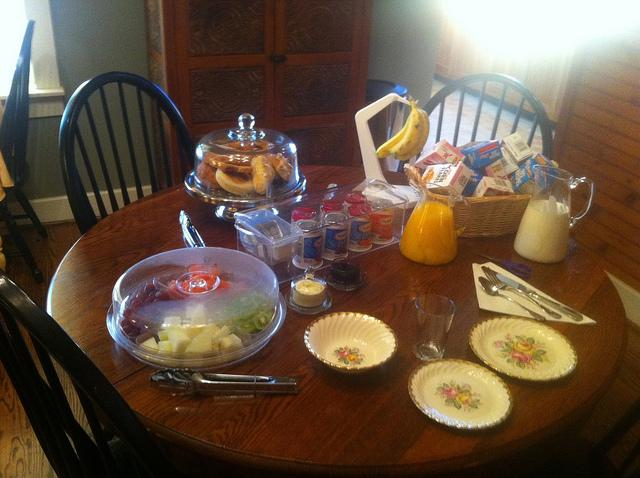What are the plastic lids used for when covering these trays of food? protection 